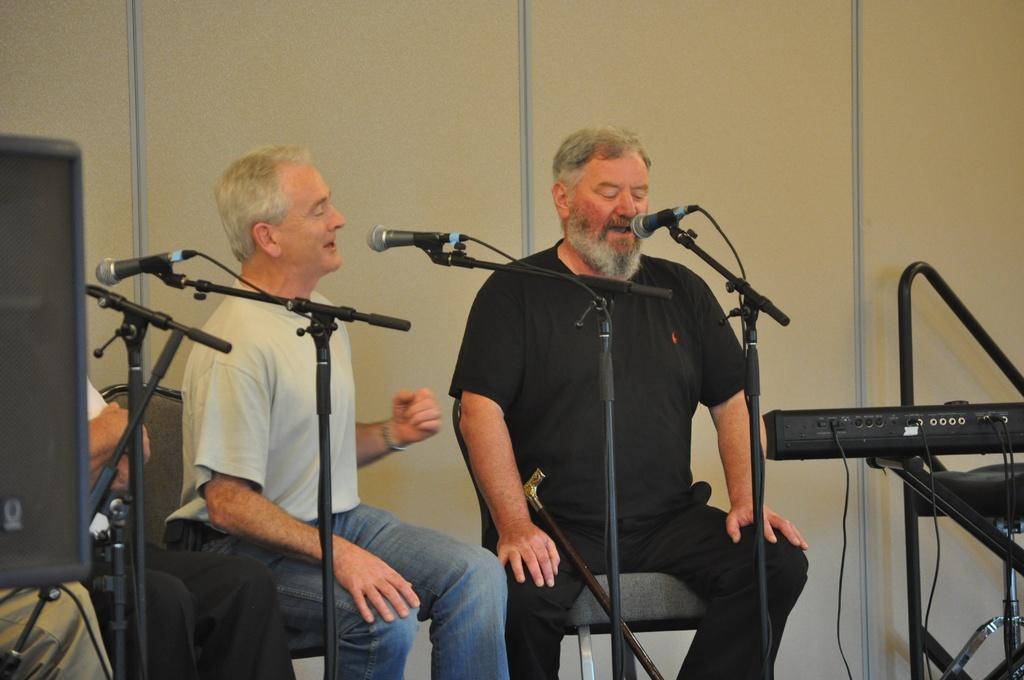Describe this image in one or two sentences. This image consists of 2 persons. They are singing something. There are mikes in the middle. There are some musical instruments in this image. 